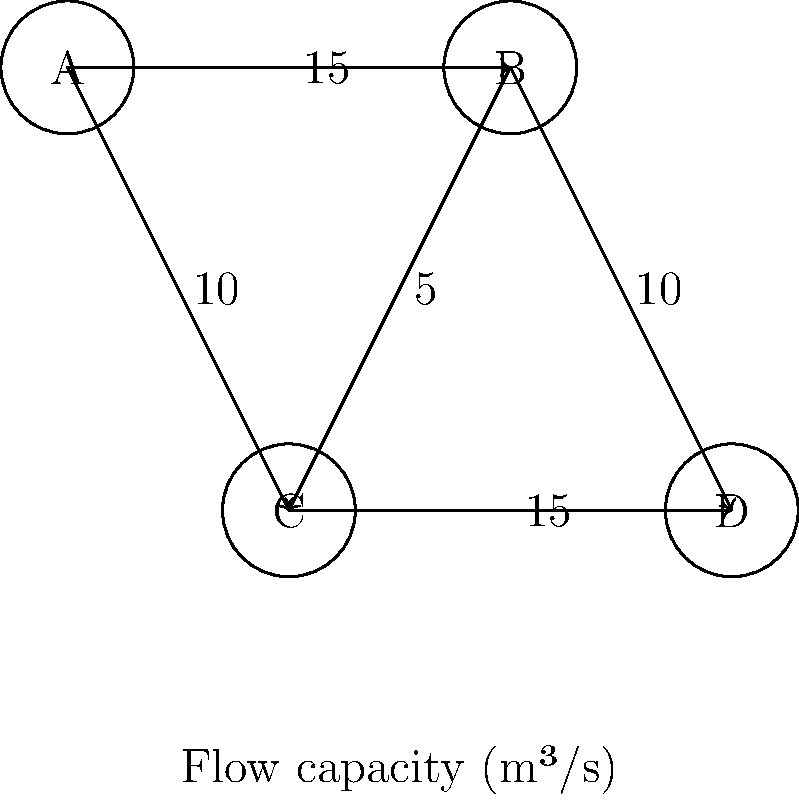As a travel blogger exploring dams worldwide, you've encountered an interconnected dam system represented by the network above. Each node represents a dam, and the edges show the maximum flow capacity between dams in cubic meters per second (m³/s). What is the maximum flow that can be sustained from dam A to dam D? To find the maximum flow from dam A to dam D, we need to use the Ford-Fulkerson algorithm or a similar max-flow algorithm. Let's solve this step-by-step:

1. Identify all possible paths from A to D:
   Path 1: A → B → D
   Path 2: A → C → D
   Path 3: A → B → C → D
   Path 4: A → C → B → D

2. Calculate the flow for each path:
   Path 1: min(15, 10) = 10 m³/s
   Path 2: min(10, 15) = 10 m³/s
   Path 3: min(15, 5, 15) = 5 m³/s
   Path 4: min(10, 5, 10) = 5 m³/s

3. Start with the maximum flow paths:
   Use Path 1: A → B → D (10 m³/s)
   Remaining capacities: AB: 5, BD: 0, AC: 10, CD: 15, BC: 5

4. Add the next maximum flow path:
   Use Path 2: A → C → D (10 m³/s)
   Remaining capacities: AB: 5, BD: 0, AC: 0, CD: 5, BC: 5

5. Check for any remaining augmenting paths:
   The only remaining path is A → B → C → D with a capacity of 5 m³/s
   Use this path: A → B → C → D (5 m³/s)

6. Sum up all the flows:
   Total flow = 10 + 10 + 5 = 25 m³/s

Therefore, the maximum flow that can be sustained from dam A to dam D is 25 m³/s.
Answer: 25 m³/s 